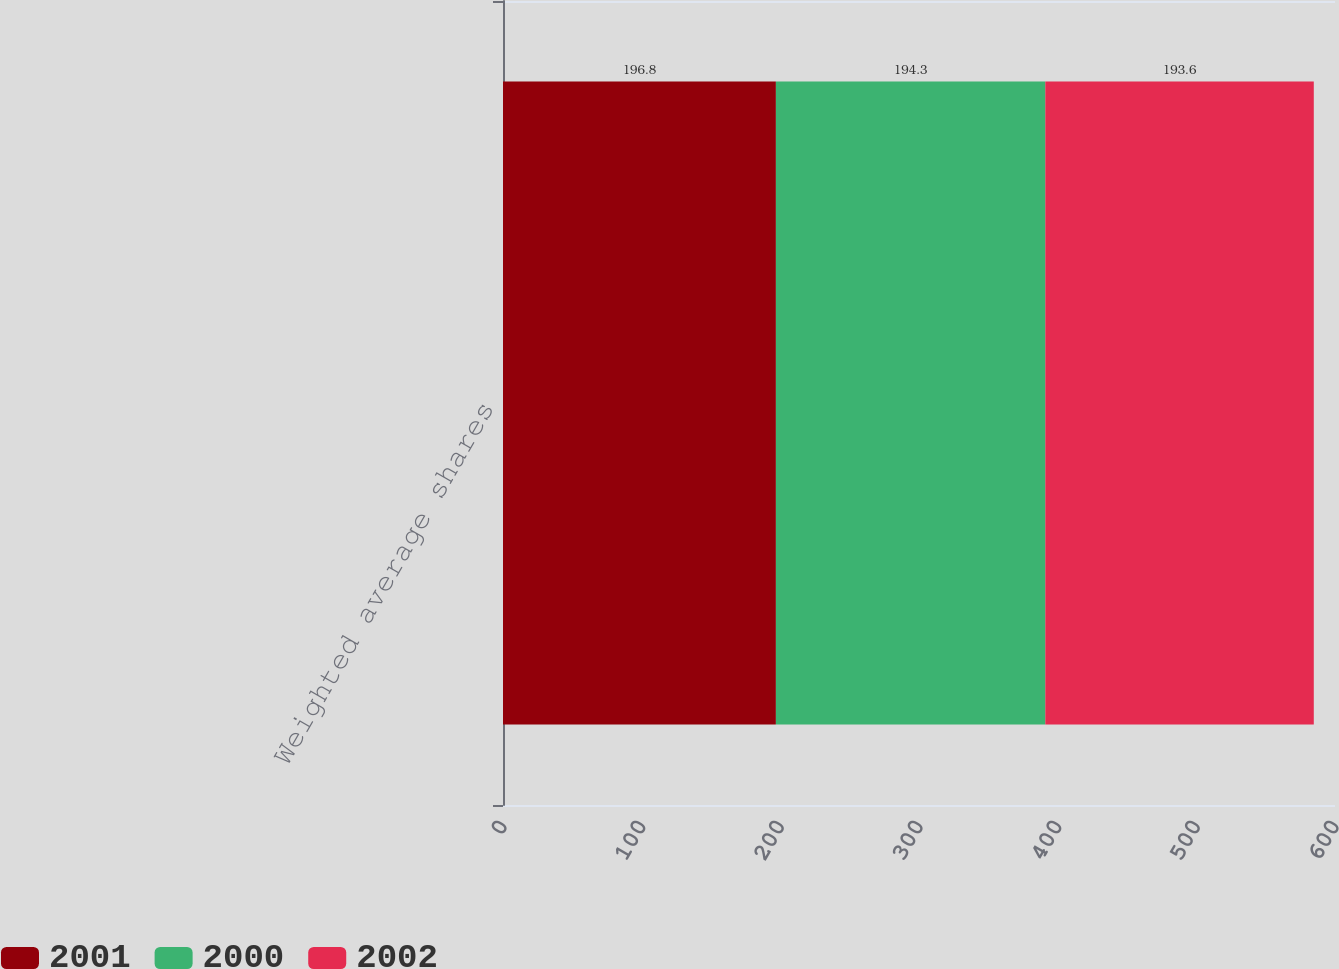<chart> <loc_0><loc_0><loc_500><loc_500><stacked_bar_chart><ecel><fcel>Weighted average shares<nl><fcel>2001<fcel>196.8<nl><fcel>2000<fcel>194.3<nl><fcel>2002<fcel>193.6<nl></chart> 